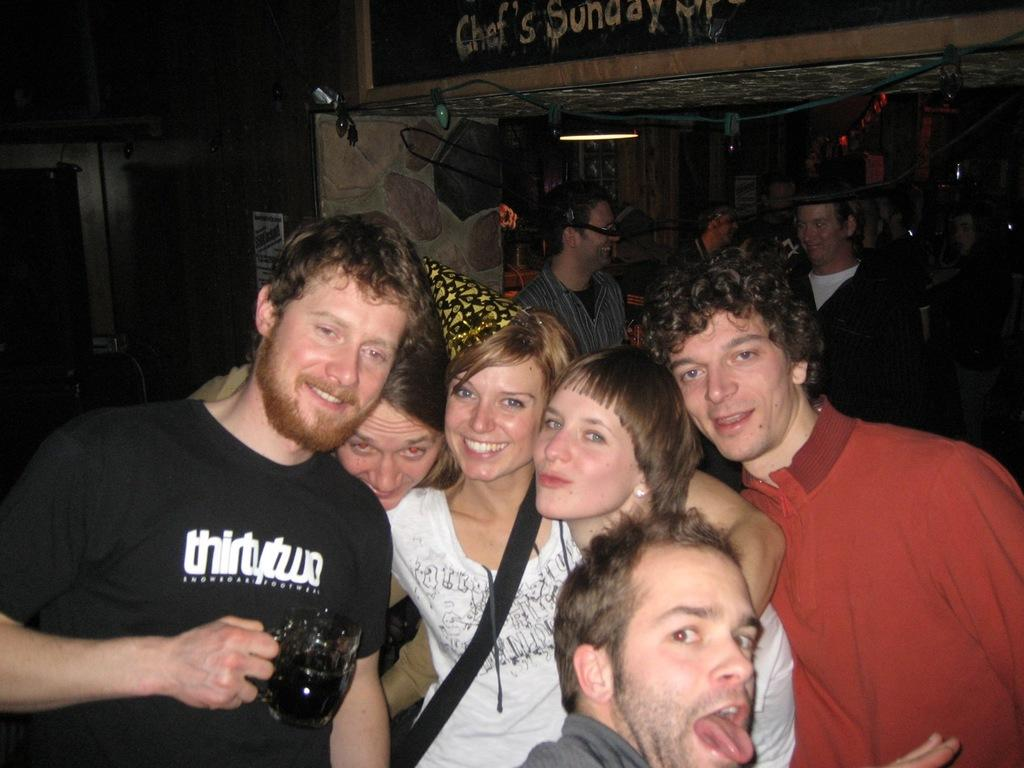<image>
Write a terse but informative summary of the picture. A group of people and one is wearing a black tshirt that says thirty two. 